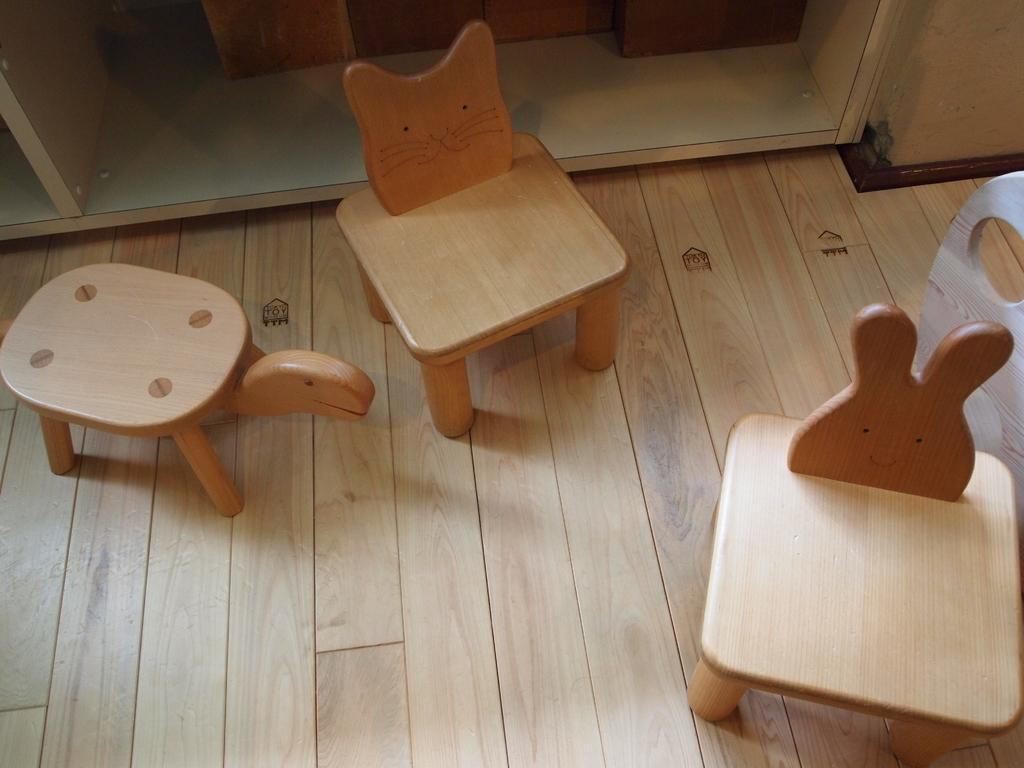What type of flooring is visible in the image? There is a wooden floor in the image. What kind of furniture is on the wooden floor? There are small wooden chairs on the floor. What can be seen in the background of the image? There is a wooden cupboard in the background of the image. What year is depicted in the image? The image does not depict a specific year; it is a photograph of a room with wooden furniture. 